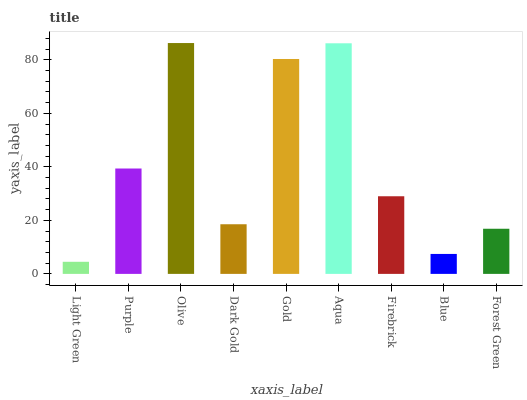Is Light Green the minimum?
Answer yes or no. Yes. Is Olive the maximum?
Answer yes or no. Yes. Is Purple the minimum?
Answer yes or no. No. Is Purple the maximum?
Answer yes or no. No. Is Purple greater than Light Green?
Answer yes or no. Yes. Is Light Green less than Purple?
Answer yes or no. Yes. Is Light Green greater than Purple?
Answer yes or no. No. Is Purple less than Light Green?
Answer yes or no. No. Is Firebrick the high median?
Answer yes or no. Yes. Is Firebrick the low median?
Answer yes or no. Yes. Is Aqua the high median?
Answer yes or no. No. Is Forest Green the low median?
Answer yes or no. No. 